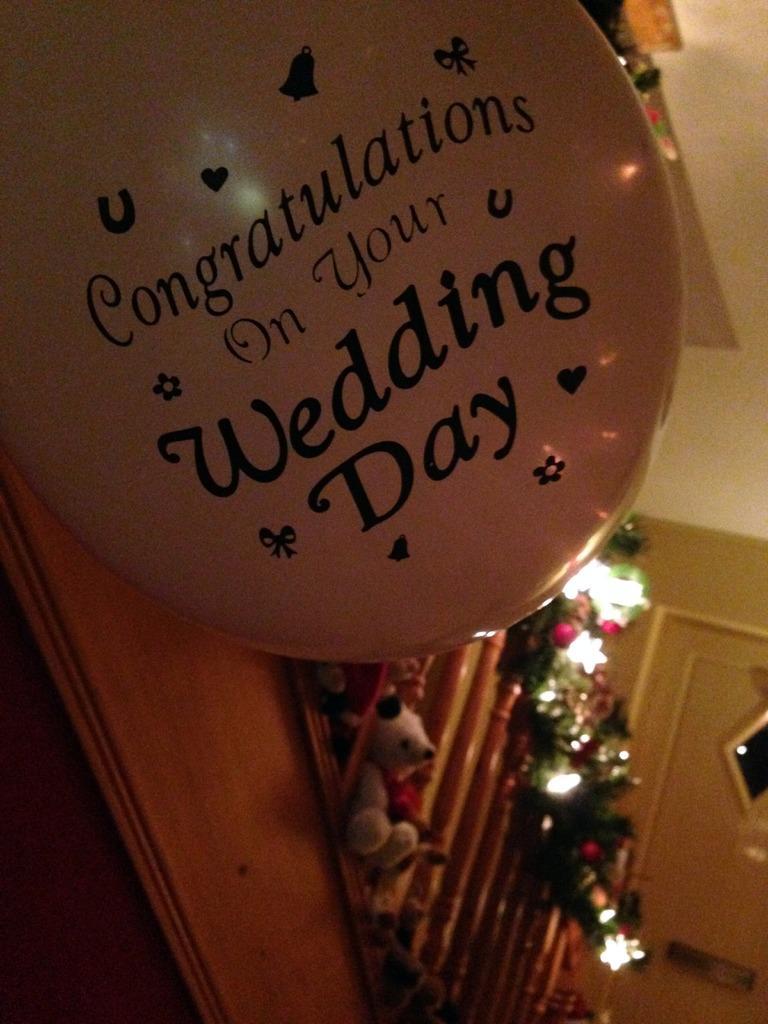Please provide a concise description of this image. In this picture I can see at the bottom there is a doll and there are lights. At the top there is a balloon with text on it. 